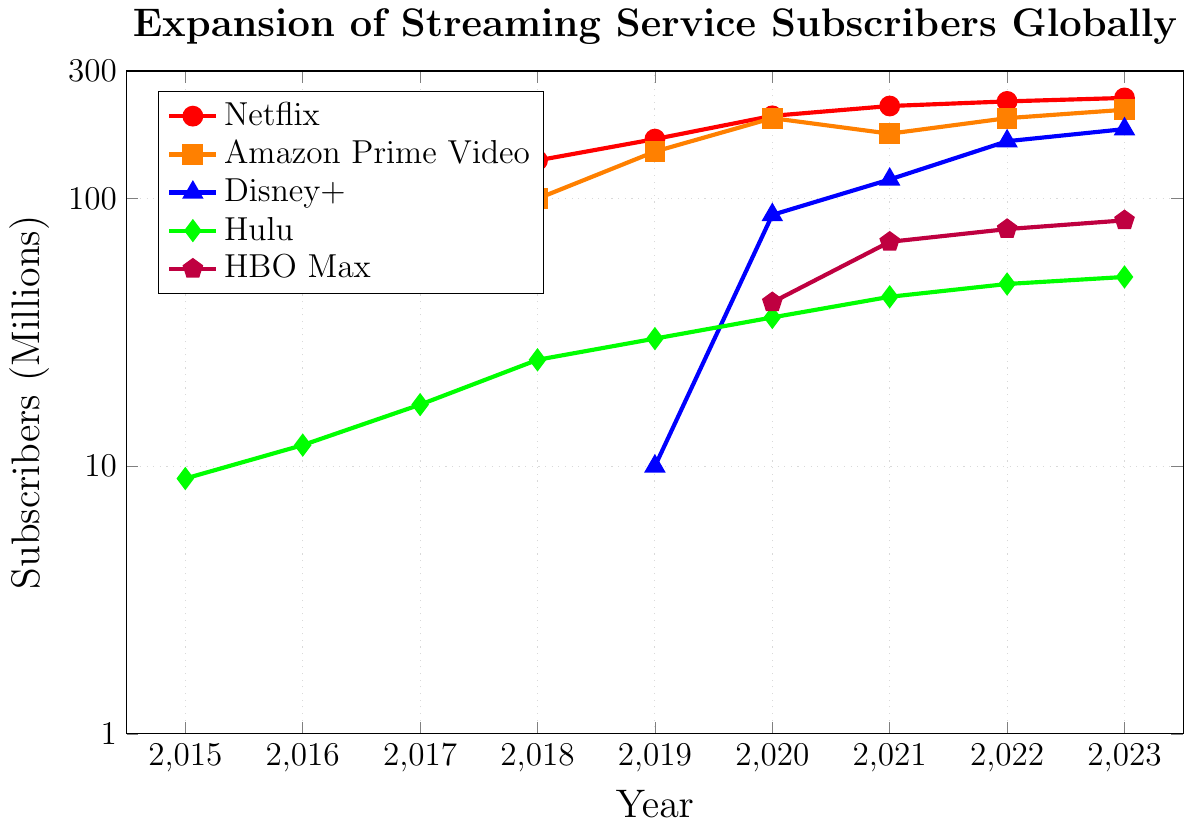What's the highest subscriber count for Netflix and in which year did it occur? By referring to the figure, we can see that the red line represents Netflix. The peak is at the value 238 million subscribers in the year 2023.
Answer: 238 million, 2023 Between which years did Amazon Prime Video see the largest increase in subscribers? Look at the orange line representing Amazon Prime Video. The largest jump is between 2018 (100 million) and 2019 (150 million), an increase of 50 million.
Answer: 2018 to 2019 How many subscribers did Hulu have in 2017, and how does it compare to the number of HBO Max subscribers in 2023? The green line for Hulu in 2017 shows 17 million subscribers. The purple line for HBO Max in 2023 shows 83 million. To compare, HBO Max has more subscribers in 2023.
Answer: Hulu: 17 million, HBO Max: 83 million What is the combined number of subscribers for Disney+ and HBO Max in 2020? For Disney+ and HBO Max in 2020, refer to the blue and purple lines respectively. Disney+ has 87 million and HBO Max has 41 million. Combined, it’s 87 + 41 = 128 million.
Answer: 128 million Which streaming service showed a continuous increase in subscribers from 2015 to 2023? By examining all lines from 2015 to 2023, we see that Netflix (red line) shows a continuous increase every year without any decrease.
Answer: Netflix Compare the number of Disney+ subscribers to Hulu subscribers in the year 2021. For 2021, Disney+ (blue line) has 118 million subscribers, and Hulu (green line) has 43 million subscribers. Disney+ has more subscribers compared to Hulu.
Answer: Disney+: 118 million, Hulu: 43 million What is the average number of Netflix subscribers over the given years? Sum the number of subscribers for Netflix from 2015 to 2023: (70 + 93 + 118 + 139 + 167 + 204 + 222 + 231 + 238) = 1482 million. Then divide by 9 (number of years) to get the average: 1482/9 = 164.67 million.
Answer: 164.67 million Based on the figure, identify the year in which Disney+ was first launched and its initial number of subscribers. The blue line representing Disney+ starts from the year 2019 with an initial 10 million subscribers.
Answer: 2019, 10 million 